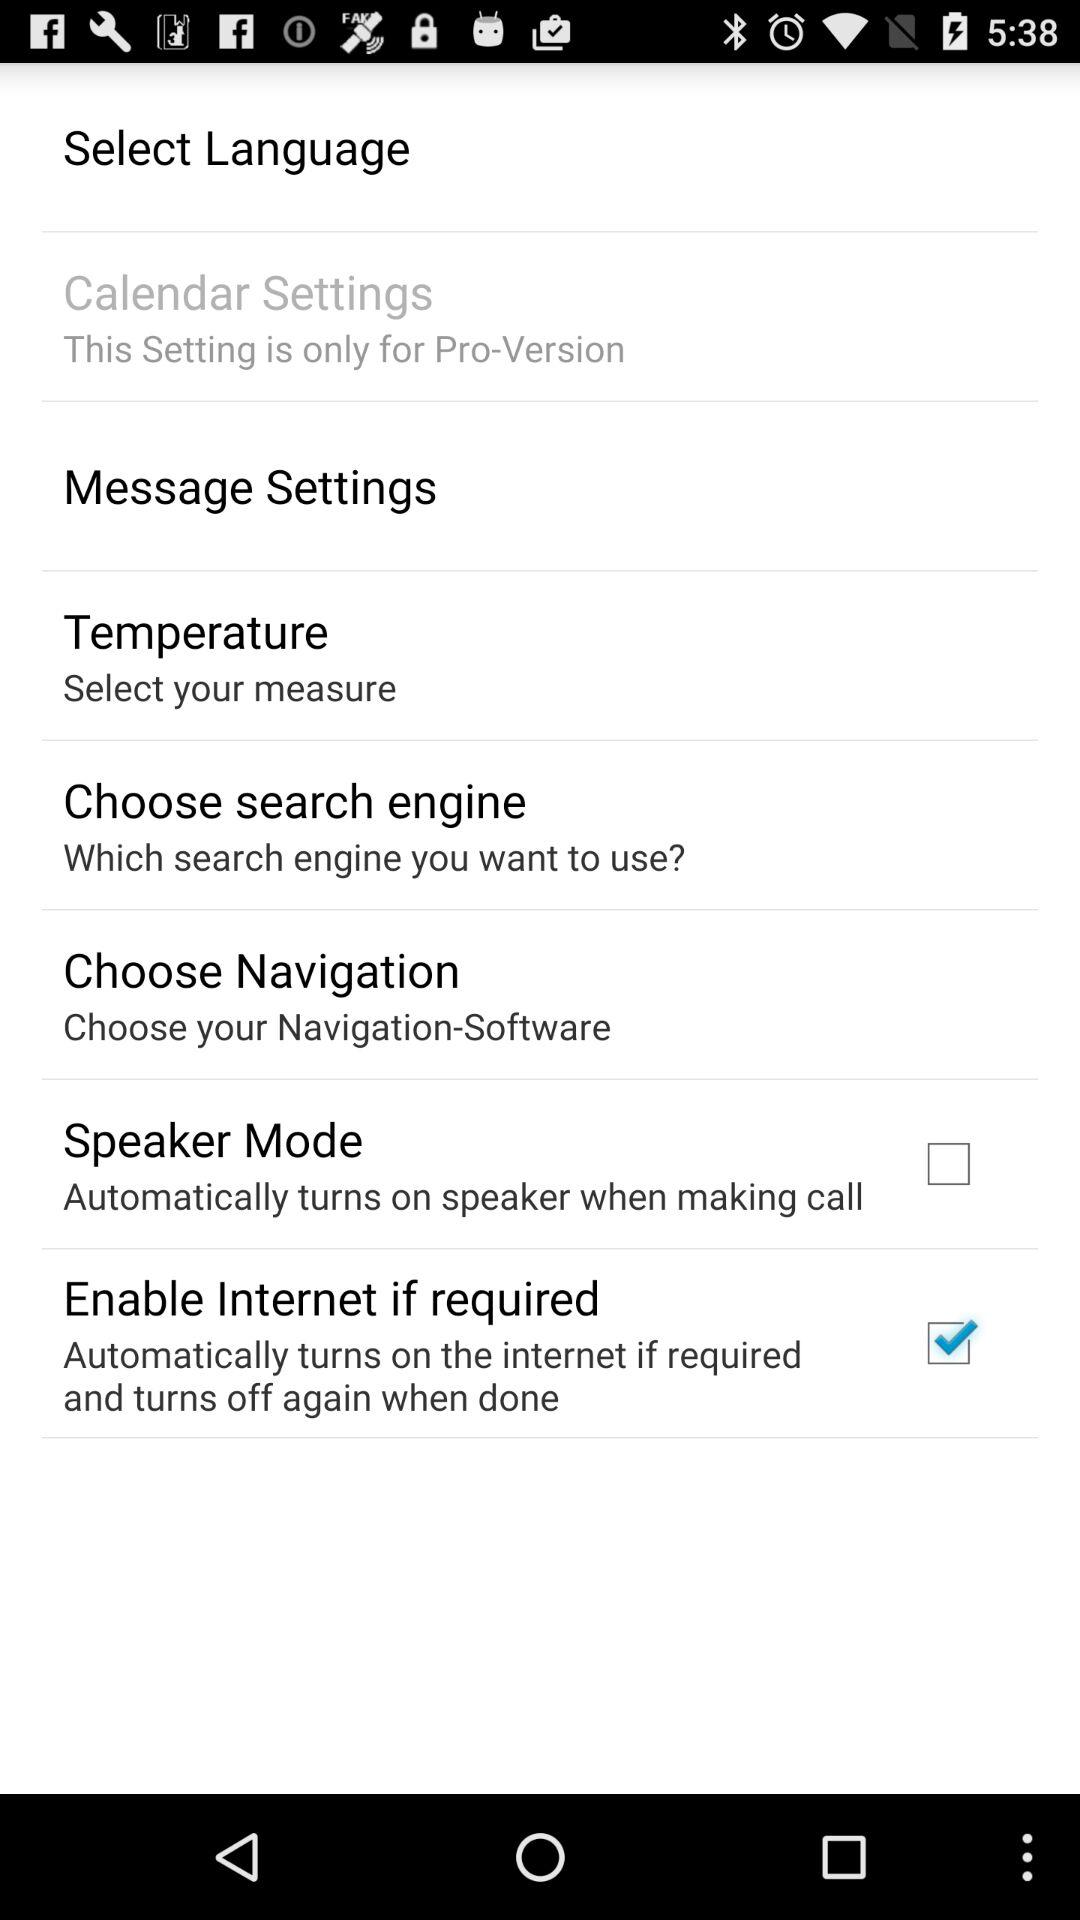What is the current state of "Speaker Mode"? The current state of "Speaker Mode" is "off". 